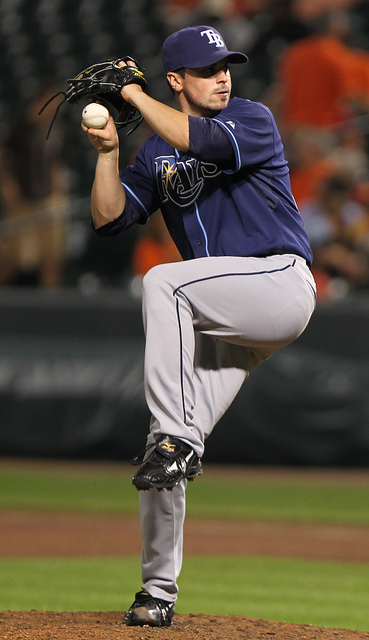<image>What finger is not inside the pitcher's glove? I don't know which finger is not inside the pitcher's glove. It can be the thumb, index, middle finger or none at all. What color is the baseball bat? There is no baseball bat in the image. What finger is not inside the pitcher's glove? I don't know what finger is not inside the pitcher's glove. It can be any finger or even none. What color is the baseball bat? There is no baseball bat in the image. It's not pictured. 